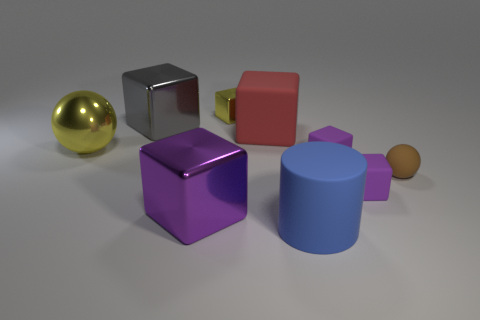How would you describe the overall composition of the shapes of the objects in this image? The image presents a collection of geometrically varied objects, including a sphere, cylinders, and cubes, with different sizes making for a simple yet intriguing study in shape and perspective. 